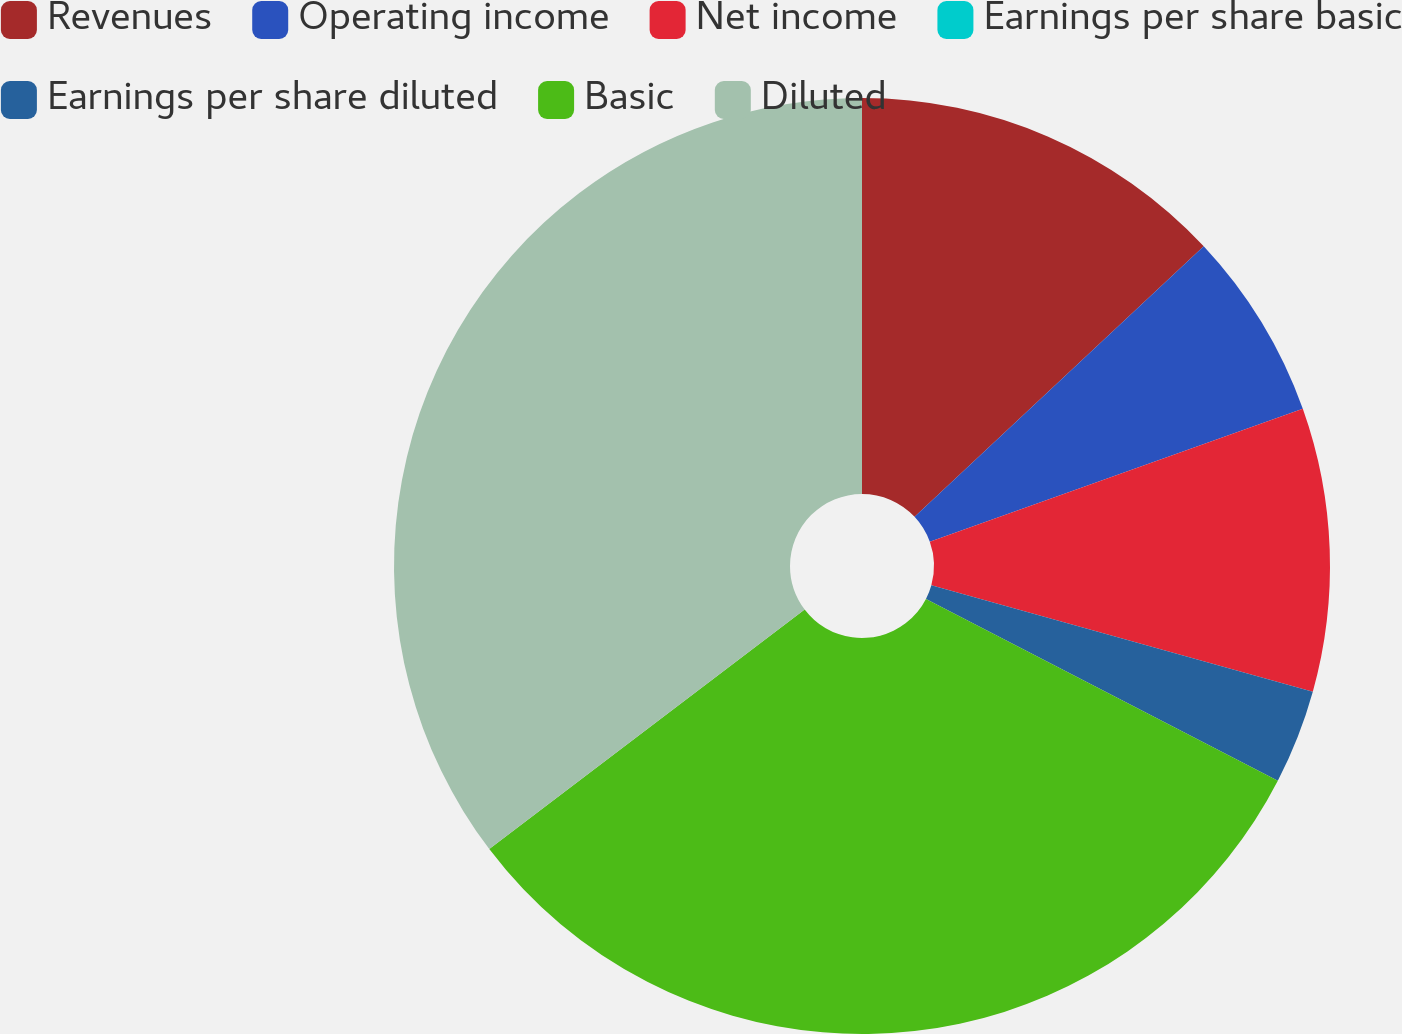Convert chart. <chart><loc_0><loc_0><loc_500><loc_500><pie_chart><fcel>Revenues<fcel>Operating income<fcel>Net income<fcel>Earnings per share basic<fcel>Earnings per share diluted<fcel>Basic<fcel>Diluted<nl><fcel>13.03%<fcel>6.52%<fcel>9.78%<fcel>0.0%<fcel>3.26%<fcel>32.08%<fcel>35.34%<nl></chart> 